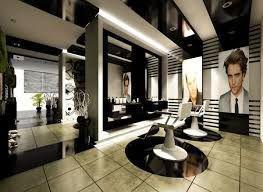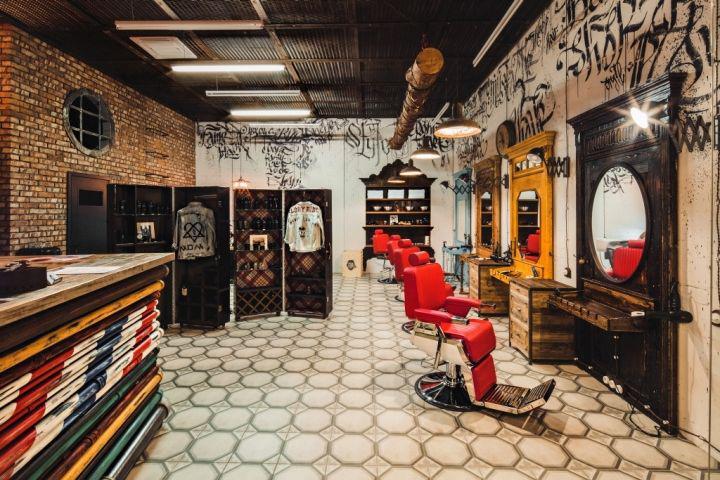The first image is the image on the left, the second image is the image on the right. For the images shown, is this caption "An exposed brick wall is shown in exactly one image." true? Answer yes or no. Yes. 